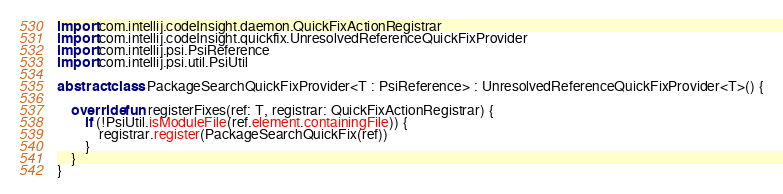<code> <loc_0><loc_0><loc_500><loc_500><_Kotlin_>
import com.intellij.codeInsight.daemon.QuickFixActionRegistrar
import com.intellij.codeInsight.quickfix.UnresolvedReferenceQuickFixProvider
import com.intellij.psi.PsiReference
import com.intellij.psi.util.PsiUtil

abstract class PackageSearchQuickFixProvider<T : PsiReference> : UnresolvedReferenceQuickFixProvider<T>() {

    override fun registerFixes(ref: T, registrar: QuickFixActionRegistrar) {
        if (!PsiUtil.isModuleFile(ref.element.containingFile)) {
            registrar.register(PackageSearchQuickFix(ref))
        }
    }
}
</code> 